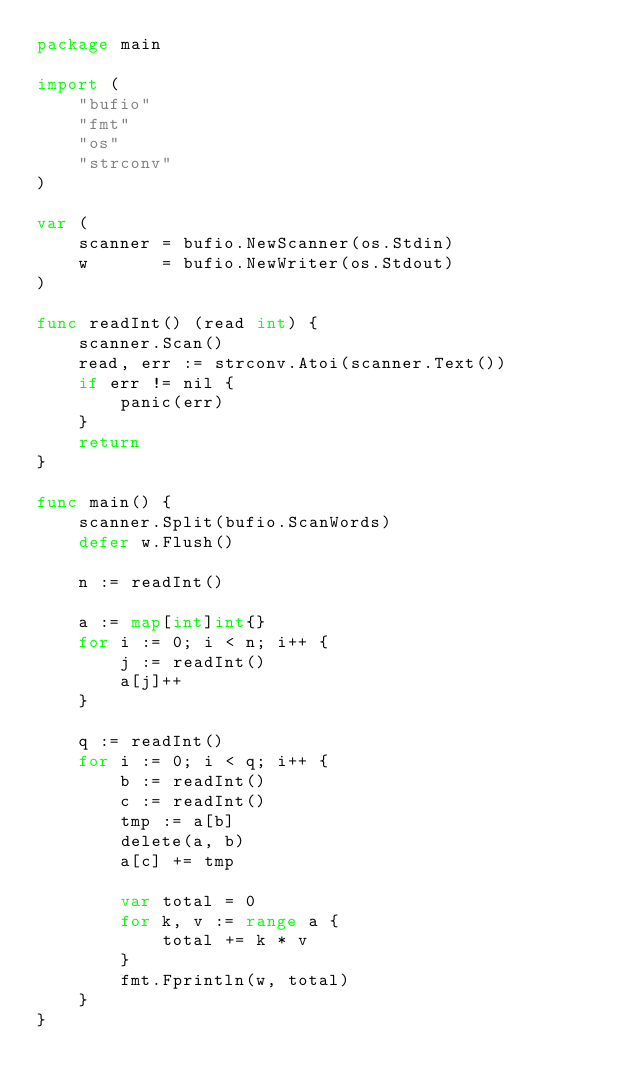Convert code to text. <code><loc_0><loc_0><loc_500><loc_500><_Go_>package main

import (
	"bufio"
	"fmt"
	"os"
	"strconv"
)

var (
	scanner = bufio.NewScanner(os.Stdin)
	w       = bufio.NewWriter(os.Stdout)
)

func readInt() (read int) {
	scanner.Scan()
	read, err := strconv.Atoi(scanner.Text())
	if err != nil {
		panic(err)
	}
	return
}

func main() {
	scanner.Split(bufio.ScanWords)
	defer w.Flush()

	n := readInt()

	a := map[int]int{}
	for i := 0; i < n; i++ {
		j := readInt()
		a[j]++
	}

	q := readInt()
	for i := 0; i < q; i++ {
		b := readInt()
		c := readInt()
		tmp := a[b]
		delete(a, b)
		a[c] += tmp

		var total = 0
		for k, v := range a {
			total += k * v
		}
		fmt.Fprintln(w, total)
	}
}
</code> 